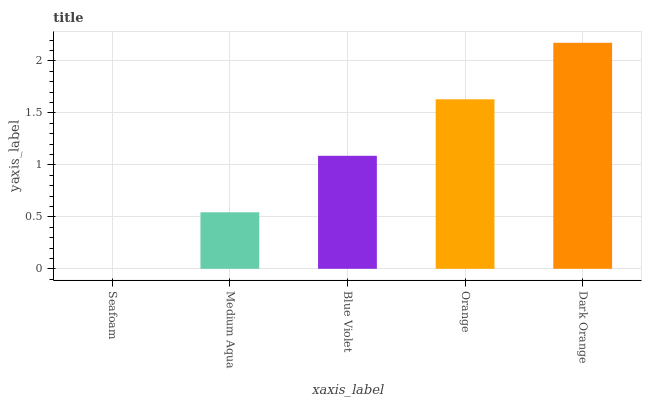Is Medium Aqua the minimum?
Answer yes or no. No. Is Medium Aqua the maximum?
Answer yes or no. No. Is Medium Aqua greater than Seafoam?
Answer yes or no. Yes. Is Seafoam less than Medium Aqua?
Answer yes or no. Yes. Is Seafoam greater than Medium Aqua?
Answer yes or no. No. Is Medium Aqua less than Seafoam?
Answer yes or no. No. Is Blue Violet the high median?
Answer yes or no. Yes. Is Blue Violet the low median?
Answer yes or no. Yes. Is Dark Orange the high median?
Answer yes or no. No. Is Orange the low median?
Answer yes or no. No. 